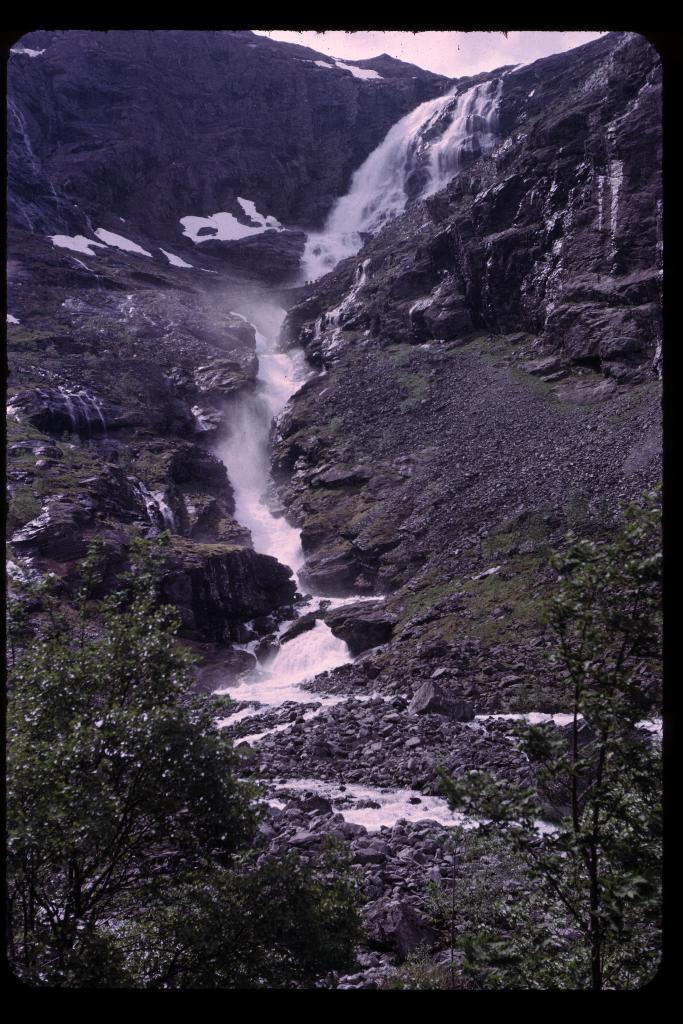How would you summarize this image in a sentence or two? In this image there is waterfall in the middle. At the bottom there are plants. In the middle there is water flowing in the line. There are stones on the ground. 